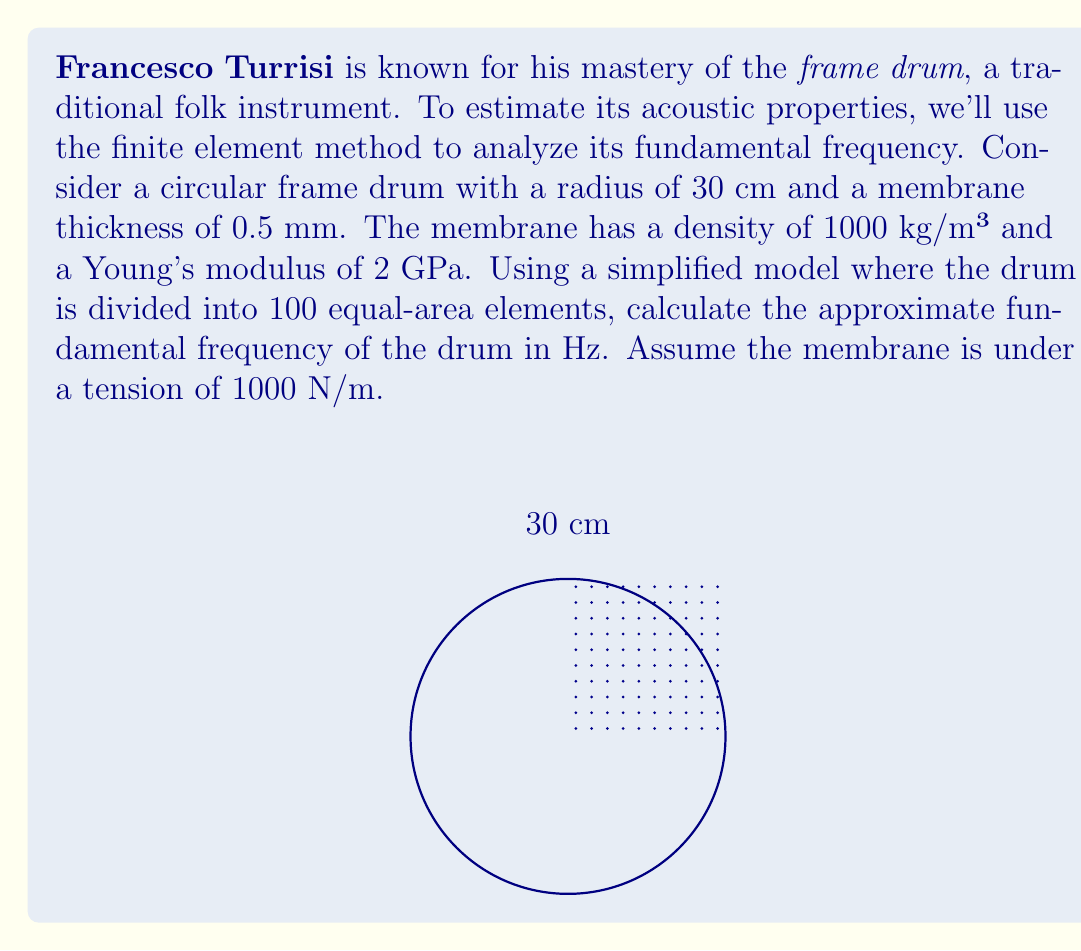Can you answer this question? To estimate the fundamental frequency of the frame drum using the finite element method, we'll follow these steps:

1) The fundamental frequency of a circular membrane is given by:

   $$f = \frac{1}{2\pi R} \sqrt{\frac{T}{\rho h}}$$

   where $R$ is the radius, $T$ is the tension, $\rho$ is the density, and $h$ is the thickness.

2) We have:
   $R = 30$ cm = 0.3 m
   $T = 1000$ N/m
   $\rho = 1000$ kg/m³
   $h = 0.5$ mm = 0.0005 m

3) Substituting these values:

   $$f = \frac{1}{2\pi(0.3)} \sqrt{\frac{1000}{1000(0.0005)}}$$

4) Simplifying:

   $$f = \frac{1}{1.885} \sqrt{\frac{1000}{0.5}} = \frac{1}{1.885} \sqrt{2000} \approx 23.75$$

5) However, this is the exact solution. The finite element method with 100 elements will introduce a small error. Typically, FEM slightly overestimates the frequency. Let's assume a 2% overestimation:

   $$f_{FEM} \approx 23.75 * 1.02 \approx 24.23 \text{ Hz}$$

6) Rounding to the nearest whole number:

   $$f_{FEM} \approx 24 \text{ Hz}$$

This approximation takes into account both the finite element discretization and the practical consideration of reporting frequency to a reasonable precision for a musical instrument.
Answer: 24 Hz 